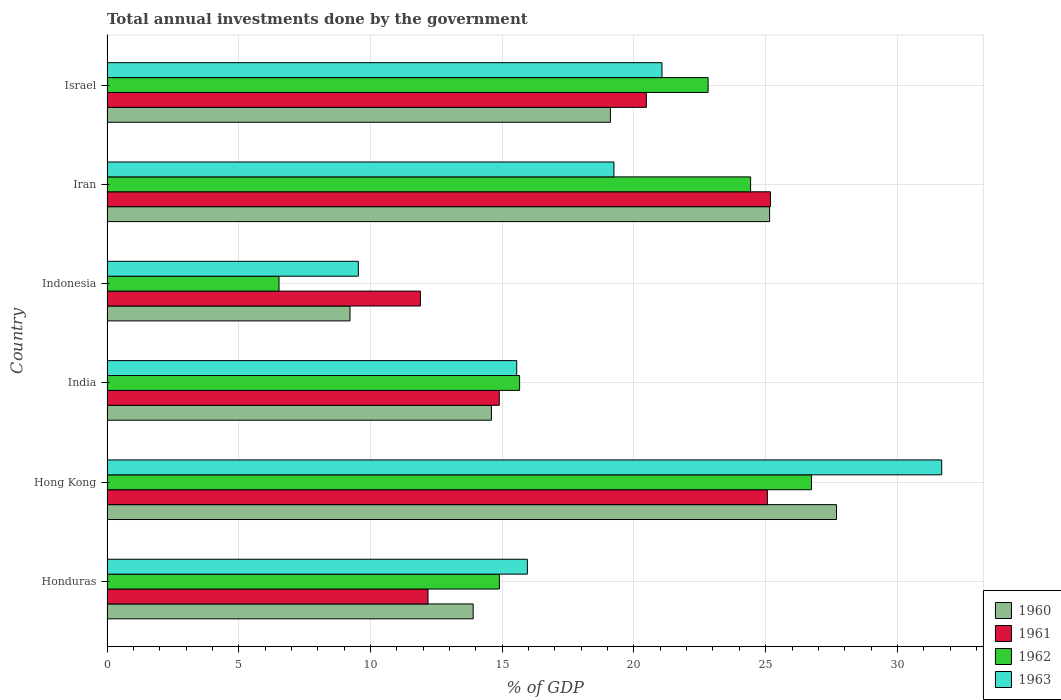Are the number of bars per tick equal to the number of legend labels?
Provide a succinct answer. Yes. What is the total annual investments done by the government in 1960 in Iran?
Make the answer very short. 25.15. Across all countries, what is the maximum total annual investments done by the government in 1962?
Give a very brief answer. 26.74. Across all countries, what is the minimum total annual investments done by the government in 1963?
Offer a terse response. 9.54. In which country was the total annual investments done by the government in 1963 maximum?
Make the answer very short. Hong Kong. What is the total total annual investments done by the government in 1961 in the graph?
Make the answer very short. 109.69. What is the difference between the total annual investments done by the government in 1960 in Honduras and that in Iran?
Make the answer very short. -11.25. What is the difference between the total annual investments done by the government in 1961 in Honduras and the total annual investments done by the government in 1963 in Israel?
Keep it short and to the point. -8.88. What is the average total annual investments done by the government in 1963 per country?
Offer a very short reply. 18.84. What is the difference between the total annual investments done by the government in 1960 and total annual investments done by the government in 1961 in India?
Your answer should be very brief. -0.3. What is the ratio of the total annual investments done by the government in 1961 in Hong Kong to that in India?
Provide a short and direct response. 1.68. Is the total annual investments done by the government in 1961 in India less than that in Indonesia?
Ensure brevity in your answer.  No. What is the difference between the highest and the second highest total annual investments done by the government in 1963?
Your answer should be compact. 10.62. What is the difference between the highest and the lowest total annual investments done by the government in 1962?
Your response must be concise. 20.21. Is it the case that in every country, the sum of the total annual investments done by the government in 1960 and total annual investments done by the government in 1961 is greater than the sum of total annual investments done by the government in 1963 and total annual investments done by the government in 1962?
Make the answer very short. No. What does the 1st bar from the top in Israel represents?
Offer a very short reply. 1963. What does the 3rd bar from the bottom in Israel represents?
Your answer should be very brief. 1962. How many bars are there?
Keep it short and to the point. 24. Are all the bars in the graph horizontal?
Give a very brief answer. Yes. How many countries are there in the graph?
Make the answer very short. 6. Does the graph contain any zero values?
Offer a very short reply. No. Does the graph contain grids?
Provide a succinct answer. Yes. Where does the legend appear in the graph?
Ensure brevity in your answer.  Bottom right. How many legend labels are there?
Your response must be concise. 4. What is the title of the graph?
Offer a terse response. Total annual investments done by the government. What is the label or title of the X-axis?
Keep it short and to the point. % of GDP. What is the % of GDP of 1960 in Honduras?
Provide a short and direct response. 13.9. What is the % of GDP in 1961 in Honduras?
Make the answer very short. 12.18. What is the % of GDP of 1962 in Honduras?
Offer a very short reply. 14.89. What is the % of GDP in 1963 in Honduras?
Your answer should be compact. 15.96. What is the % of GDP in 1960 in Hong Kong?
Your answer should be very brief. 27.69. What is the % of GDP in 1961 in Hong Kong?
Provide a short and direct response. 25.06. What is the % of GDP in 1962 in Hong Kong?
Provide a short and direct response. 26.74. What is the % of GDP in 1963 in Hong Kong?
Give a very brief answer. 31.68. What is the % of GDP in 1960 in India?
Provide a short and direct response. 14.59. What is the % of GDP of 1961 in India?
Your response must be concise. 14.89. What is the % of GDP of 1962 in India?
Your response must be concise. 15.66. What is the % of GDP in 1963 in India?
Give a very brief answer. 15.55. What is the % of GDP in 1960 in Indonesia?
Your response must be concise. 9.22. What is the % of GDP of 1961 in Indonesia?
Provide a short and direct response. 11.9. What is the % of GDP of 1962 in Indonesia?
Ensure brevity in your answer.  6.53. What is the % of GDP of 1963 in Indonesia?
Your answer should be compact. 9.54. What is the % of GDP in 1960 in Iran?
Your answer should be very brief. 25.15. What is the % of GDP of 1961 in Iran?
Your answer should be very brief. 25.18. What is the % of GDP of 1962 in Iran?
Make the answer very short. 24.43. What is the % of GDP of 1963 in Iran?
Make the answer very short. 19.24. What is the % of GDP of 1960 in Israel?
Your response must be concise. 19.11. What is the % of GDP in 1961 in Israel?
Give a very brief answer. 20.47. What is the % of GDP of 1962 in Israel?
Offer a very short reply. 22.82. What is the % of GDP in 1963 in Israel?
Provide a succinct answer. 21.06. Across all countries, what is the maximum % of GDP in 1960?
Give a very brief answer. 27.69. Across all countries, what is the maximum % of GDP in 1961?
Keep it short and to the point. 25.18. Across all countries, what is the maximum % of GDP of 1962?
Your answer should be very brief. 26.74. Across all countries, what is the maximum % of GDP of 1963?
Keep it short and to the point. 31.68. Across all countries, what is the minimum % of GDP in 1960?
Keep it short and to the point. 9.22. Across all countries, what is the minimum % of GDP in 1961?
Keep it short and to the point. 11.9. Across all countries, what is the minimum % of GDP in 1962?
Your response must be concise. 6.53. Across all countries, what is the minimum % of GDP of 1963?
Ensure brevity in your answer.  9.54. What is the total % of GDP of 1960 in the graph?
Ensure brevity in your answer.  109.66. What is the total % of GDP of 1961 in the graph?
Give a very brief answer. 109.69. What is the total % of GDP in 1962 in the graph?
Your response must be concise. 111.07. What is the total % of GDP of 1963 in the graph?
Give a very brief answer. 113.04. What is the difference between the % of GDP of 1960 in Honduras and that in Hong Kong?
Keep it short and to the point. -13.79. What is the difference between the % of GDP in 1961 in Honduras and that in Hong Kong?
Offer a very short reply. -12.88. What is the difference between the % of GDP of 1962 in Honduras and that in Hong Kong?
Make the answer very short. -11.84. What is the difference between the % of GDP of 1963 in Honduras and that in Hong Kong?
Your response must be concise. -15.73. What is the difference between the % of GDP of 1960 in Honduras and that in India?
Your response must be concise. -0.69. What is the difference between the % of GDP in 1961 in Honduras and that in India?
Your answer should be compact. -2.7. What is the difference between the % of GDP in 1962 in Honduras and that in India?
Offer a very short reply. -0.77. What is the difference between the % of GDP in 1963 in Honduras and that in India?
Keep it short and to the point. 0.4. What is the difference between the % of GDP of 1960 in Honduras and that in Indonesia?
Offer a terse response. 4.68. What is the difference between the % of GDP in 1961 in Honduras and that in Indonesia?
Give a very brief answer. 0.29. What is the difference between the % of GDP of 1962 in Honduras and that in Indonesia?
Ensure brevity in your answer.  8.36. What is the difference between the % of GDP of 1963 in Honduras and that in Indonesia?
Offer a very short reply. 6.42. What is the difference between the % of GDP in 1960 in Honduras and that in Iran?
Keep it short and to the point. -11.25. What is the difference between the % of GDP of 1961 in Honduras and that in Iran?
Your answer should be compact. -13. What is the difference between the % of GDP of 1962 in Honduras and that in Iran?
Your response must be concise. -9.54. What is the difference between the % of GDP of 1963 in Honduras and that in Iran?
Offer a very short reply. -3.29. What is the difference between the % of GDP in 1960 in Honduras and that in Israel?
Make the answer very short. -5.21. What is the difference between the % of GDP in 1961 in Honduras and that in Israel?
Ensure brevity in your answer.  -8.29. What is the difference between the % of GDP in 1962 in Honduras and that in Israel?
Give a very brief answer. -7.92. What is the difference between the % of GDP in 1963 in Honduras and that in Israel?
Provide a succinct answer. -5.11. What is the difference between the % of GDP in 1960 in Hong Kong and that in India?
Provide a short and direct response. 13.1. What is the difference between the % of GDP of 1961 in Hong Kong and that in India?
Your response must be concise. 10.18. What is the difference between the % of GDP of 1962 in Hong Kong and that in India?
Ensure brevity in your answer.  11.08. What is the difference between the % of GDP in 1963 in Hong Kong and that in India?
Make the answer very short. 16.13. What is the difference between the % of GDP in 1960 in Hong Kong and that in Indonesia?
Offer a very short reply. 18.47. What is the difference between the % of GDP in 1961 in Hong Kong and that in Indonesia?
Provide a succinct answer. 13.17. What is the difference between the % of GDP in 1962 in Hong Kong and that in Indonesia?
Make the answer very short. 20.21. What is the difference between the % of GDP in 1963 in Hong Kong and that in Indonesia?
Provide a succinct answer. 22.14. What is the difference between the % of GDP in 1960 in Hong Kong and that in Iran?
Your response must be concise. 2.54. What is the difference between the % of GDP in 1961 in Hong Kong and that in Iran?
Offer a very short reply. -0.12. What is the difference between the % of GDP of 1962 in Hong Kong and that in Iran?
Provide a succinct answer. 2.31. What is the difference between the % of GDP in 1963 in Hong Kong and that in Iran?
Make the answer very short. 12.44. What is the difference between the % of GDP in 1960 in Hong Kong and that in Israel?
Keep it short and to the point. 8.58. What is the difference between the % of GDP in 1961 in Hong Kong and that in Israel?
Provide a short and direct response. 4.59. What is the difference between the % of GDP in 1962 in Hong Kong and that in Israel?
Offer a terse response. 3.92. What is the difference between the % of GDP of 1963 in Hong Kong and that in Israel?
Your answer should be very brief. 10.62. What is the difference between the % of GDP of 1960 in India and that in Indonesia?
Offer a terse response. 5.37. What is the difference between the % of GDP of 1961 in India and that in Indonesia?
Your answer should be very brief. 2.99. What is the difference between the % of GDP in 1962 in India and that in Indonesia?
Offer a terse response. 9.13. What is the difference between the % of GDP of 1963 in India and that in Indonesia?
Give a very brief answer. 6.01. What is the difference between the % of GDP of 1960 in India and that in Iran?
Provide a short and direct response. -10.56. What is the difference between the % of GDP of 1961 in India and that in Iran?
Keep it short and to the point. -10.29. What is the difference between the % of GDP of 1962 in India and that in Iran?
Ensure brevity in your answer.  -8.77. What is the difference between the % of GDP in 1963 in India and that in Iran?
Provide a short and direct response. -3.69. What is the difference between the % of GDP in 1960 in India and that in Israel?
Your response must be concise. -4.52. What is the difference between the % of GDP in 1961 in India and that in Israel?
Ensure brevity in your answer.  -5.58. What is the difference between the % of GDP in 1962 in India and that in Israel?
Your answer should be very brief. -7.15. What is the difference between the % of GDP of 1963 in India and that in Israel?
Offer a very short reply. -5.51. What is the difference between the % of GDP of 1960 in Indonesia and that in Iran?
Offer a very short reply. -15.93. What is the difference between the % of GDP of 1961 in Indonesia and that in Iran?
Ensure brevity in your answer.  -13.29. What is the difference between the % of GDP of 1962 in Indonesia and that in Iran?
Provide a succinct answer. -17.9. What is the difference between the % of GDP of 1963 in Indonesia and that in Iran?
Your response must be concise. -9.7. What is the difference between the % of GDP in 1960 in Indonesia and that in Israel?
Offer a terse response. -9.88. What is the difference between the % of GDP of 1961 in Indonesia and that in Israel?
Provide a succinct answer. -8.58. What is the difference between the % of GDP of 1962 in Indonesia and that in Israel?
Keep it short and to the point. -16.29. What is the difference between the % of GDP in 1963 in Indonesia and that in Israel?
Offer a terse response. -11.53. What is the difference between the % of GDP in 1960 in Iran and that in Israel?
Offer a very short reply. 6.04. What is the difference between the % of GDP of 1961 in Iran and that in Israel?
Offer a very short reply. 4.71. What is the difference between the % of GDP of 1962 in Iran and that in Israel?
Offer a very short reply. 1.61. What is the difference between the % of GDP of 1963 in Iran and that in Israel?
Your response must be concise. -1.82. What is the difference between the % of GDP of 1960 in Honduras and the % of GDP of 1961 in Hong Kong?
Your answer should be very brief. -11.17. What is the difference between the % of GDP in 1960 in Honduras and the % of GDP in 1962 in Hong Kong?
Provide a short and direct response. -12.84. What is the difference between the % of GDP of 1960 in Honduras and the % of GDP of 1963 in Hong Kong?
Provide a short and direct response. -17.78. What is the difference between the % of GDP of 1961 in Honduras and the % of GDP of 1962 in Hong Kong?
Offer a very short reply. -14.55. What is the difference between the % of GDP of 1961 in Honduras and the % of GDP of 1963 in Hong Kong?
Make the answer very short. -19.5. What is the difference between the % of GDP of 1962 in Honduras and the % of GDP of 1963 in Hong Kong?
Ensure brevity in your answer.  -16.79. What is the difference between the % of GDP of 1960 in Honduras and the % of GDP of 1961 in India?
Your response must be concise. -0.99. What is the difference between the % of GDP in 1960 in Honduras and the % of GDP in 1962 in India?
Make the answer very short. -1.76. What is the difference between the % of GDP in 1960 in Honduras and the % of GDP in 1963 in India?
Offer a very short reply. -1.65. What is the difference between the % of GDP of 1961 in Honduras and the % of GDP of 1962 in India?
Your response must be concise. -3.48. What is the difference between the % of GDP of 1961 in Honduras and the % of GDP of 1963 in India?
Your response must be concise. -3.37. What is the difference between the % of GDP of 1962 in Honduras and the % of GDP of 1963 in India?
Give a very brief answer. -0.66. What is the difference between the % of GDP of 1960 in Honduras and the % of GDP of 1961 in Indonesia?
Your answer should be very brief. 2. What is the difference between the % of GDP in 1960 in Honduras and the % of GDP in 1962 in Indonesia?
Your answer should be very brief. 7.37. What is the difference between the % of GDP in 1960 in Honduras and the % of GDP in 1963 in Indonesia?
Your response must be concise. 4.36. What is the difference between the % of GDP of 1961 in Honduras and the % of GDP of 1962 in Indonesia?
Offer a very short reply. 5.65. What is the difference between the % of GDP of 1961 in Honduras and the % of GDP of 1963 in Indonesia?
Provide a short and direct response. 2.64. What is the difference between the % of GDP in 1962 in Honduras and the % of GDP in 1963 in Indonesia?
Keep it short and to the point. 5.35. What is the difference between the % of GDP of 1960 in Honduras and the % of GDP of 1961 in Iran?
Give a very brief answer. -11.28. What is the difference between the % of GDP in 1960 in Honduras and the % of GDP in 1962 in Iran?
Ensure brevity in your answer.  -10.53. What is the difference between the % of GDP in 1960 in Honduras and the % of GDP in 1963 in Iran?
Give a very brief answer. -5.34. What is the difference between the % of GDP of 1961 in Honduras and the % of GDP of 1962 in Iran?
Make the answer very short. -12.24. What is the difference between the % of GDP of 1961 in Honduras and the % of GDP of 1963 in Iran?
Your answer should be compact. -7.06. What is the difference between the % of GDP of 1962 in Honduras and the % of GDP of 1963 in Iran?
Offer a very short reply. -4.35. What is the difference between the % of GDP in 1960 in Honduras and the % of GDP in 1961 in Israel?
Your answer should be very brief. -6.57. What is the difference between the % of GDP of 1960 in Honduras and the % of GDP of 1962 in Israel?
Provide a succinct answer. -8.92. What is the difference between the % of GDP in 1960 in Honduras and the % of GDP in 1963 in Israel?
Offer a very short reply. -7.17. What is the difference between the % of GDP in 1961 in Honduras and the % of GDP in 1962 in Israel?
Ensure brevity in your answer.  -10.63. What is the difference between the % of GDP of 1961 in Honduras and the % of GDP of 1963 in Israel?
Keep it short and to the point. -8.88. What is the difference between the % of GDP of 1962 in Honduras and the % of GDP of 1963 in Israel?
Offer a very short reply. -6.17. What is the difference between the % of GDP of 1960 in Hong Kong and the % of GDP of 1961 in India?
Keep it short and to the point. 12.8. What is the difference between the % of GDP of 1960 in Hong Kong and the % of GDP of 1962 in India?
Ensure brevity in your answer.  12.03. What is the difference between the % of GDP in 1960 in Hong Kong and the % of GDP in 1963 in India?
Offer a terse response. 12.14. What is the difference between the % of GDP in 1961 in Hong Kong and the % of GDP in 1962 in India?
Offer a very short reply. 9.4. What is the difference between the % of GDP of 1961 in Hong Kong and the % of GDP of 1963 in India?
Provide a short and direct response. 9.51. What is the difference between the % of GDP in 1962 in Hong Kong and the % of GDP in 1963 in India?
Give a very brief answer. 11.19. What is the difference between the % of GDP of 1960 in Hong Kong and the % of GDP of 1961 in Indonesia?
Your answer should be very brief. 15.79. What is the difference between the % of GDP in 1960 in Hong Kong and the % of GDP in 1962 in Indonesia?
Provide a short and direct response. 21.16. What is the difference between the % of GDP in 1960 in Hong Kong and the % of GDP in 1963 in Indonesia?
Your response must be concise. 18.15. What is the difference between the % of GDP in 1961 in Hong Kong and the % of GDP in 1962 in Indonesia?
Provide a short and direct response. 18.54. What is the difference between the % of GDP in 1961 in Hong Kong and the % of GDP in 1963 in Indonesia?
Offer a very short reply. 15.53. What is the difference between the % of GDP of 1962 in Hong Kong and the % of GDP of 1963 in Indonesia?
Your answer should be very brief. 17.2. What is the difference between the % of GDP of 1960 in Hong Kong and the % of GDP of 1961 in Iran?
Your response must be concise. 2.51. What is the difference between the % of GDP of 1960 in Hong Kong and the % of GDP of 1962 in Iran?
Ensure brevity in your answer.  3.26. What is the difference between the % of GDP in 1960 in Hong Kong and the % of GDP in 1963 in Iran?
Your response must be concise. 8.45. What is the difference between the % of GDP of 1961 in Hong Kong and the % of GDP of 1962 in Iran?
Ensure brevity in your answer.  0.64. What is the difference between the % of GDP in 1961 in Hong Kong and the % of GDP in 1963 in Iran?
Provide a short and direct response. 5.82. What is the difference between the % of GDP of 1962 in Hong Kong and the % of GDP of 1963 in Iran?
Give a very brief answer. 7.5. What is the difference between the % of GDP of 1960 in Hong Kong and the % of GDP of 1961 in Israel?
Offer a very short reply. 7.22. What is the difference between the % of GDP of 1960 in Hong Kong and the % of GDP of 1962 in Israel?
Provide a short and direct response. 4.87. What is the difference between the % of GDP in 1960 in Hong Kong and the % of GDP in 1963 in Israel?
Your response must be concise. 6.62. What is the difference between the % of GDP in 1961 in Hong Kong and the % of GDP in 1962 in Israel?
Ensure brevity in your answer.  2.25. What is the difference between the % of GDP of 1961 in Hong Kong and the % of GDP of 1963 in Israel?
Your answer should be compact. 4. What is the difference between the % of GDP of 1962 in Hong Kong and the % of GDP of 1963 in Israel?
Offer a very short reply. 5.67. What is the difference between the % of GDP of 1960 in India and the % of GDP of 1961 in Indonesia?
Make the answer very short. 2.7. What is the difference between the % of GDP of 1960 in India and the % of GDP of 1962 in Indonesia?
Keep it short and to the point. 8.06. What is the difference between the % of GDP in 1960 in India and the % of GDP in 1963 in Indonesia?
Make the answer very short. 5.05. What is the difference between the % of GDP in 1961 in India and the % of GDP in 1962 in Indonesia?
Keep it short and to the point. 8.36. What is the difference between the % of GDP of 1961 in India and the % of GDP of 1963 in Indonesia?
Your response must be concise. 5.35. What is the difference between the % of GDP of 1962 in India and the % of GDP of 1963 in Indonesia?
Offer a terse response. 6.12. What is the difference between the % of GDP of 1960 in India and the % of GDP of 1961 in Iran?
Ensure brevity in your answer.  -10.59. What is the difference between the % of GDP in 1960 in India and the % of GDP in 1962 in Iran?
Your answer should be compact. -9.84. What is the difference between the % of GDP of 1960 in India and the % of GDP of 1963 in Iran?
Provide a succinct answer. -4.65. What is the difference between the % of GDP in 1961 in India and the % of GDP in 1962 in Iran?
Your answer should be very brief. -9.54. What is the difference between the % of GDP in 1961 in India and the % of GDP in 1963 in Iran?
Your response must be concise. -4.35. What is the difference between the % of GDP in 1962 in India and the % of GDP in 1963 in Iran?
Your answer should be very brief. -3.58. What is the difference between the % of GDP of 1960 in India and the % of GDP of 1961 in Israel?
Keep it short and to the point. -5.88. What is the difference between the % of GDP in 1960 in India and the % of GDP in 1962 in Israel?
Your answer should be compact. -8.22. What is the difference between the % of GDP in 1960 in India and the % of GDP in 1963 in Israel?
Make the answer very short. -6.47. What is the difference between the % of GDP of 1961 in India and the % of GDP of 1962 in Israel?
Ensure brevity in your answer.  -7.93. What is the difference between the % of GDP of 1961 in India and the % of GDP of 1963 in Israel?
Give a very brief answer. -6.18. What is the difference between the % of GDP of 1962 in India and the % of GDP of 1963 in Israel?
Offer a very short reply. -5.4. What is the difference between the % of GDP of 1960 in Indonesia and the % of GDP of 1961 in Iran?
Your response must be concise. -15.96. What is the difference between the % of GDP of 1960 in Indonesia and the % of GDP of 1962 in Iran?
Offer a terse response. -15.21. What is the difference between the % of GDP in 1960 in Indonesia and the % of GDP in 1963 in Iran?
Provide a succinct answer. -10.02. What is the difference between the % of GDP of 1961 in Indonesia and the % of GDP of 1962 in Iran?
Offer a very short reply. -12.53. What is the difference between the % of GDP in 1961 in Indonesia and the % of GDP in 1963 in Iran?
Make the answer very short. -7.35. What is the difference between the % of GDP of 1962 in Indonesia and the % of GDP of 1963 in Iran?
Give a very brief answer. -12.71. What is the difference between the % of GDP in 1960 in Indonesia and the % of GDP in 1961 in Israel?
Your response must be concise. -11.25. What is the difference between the % of GDP in 1960 in Indonesia and the % of GDP in 1962 in Israel?
Your response must be concise. -13.59. What is the difference between the % of GDP of 1960 in Indonesia and the % of GDP of 1963 in Israel?
Your response must be concise. -11.84. What is the difference between the % of GDP in 1961 in Indonesia and the % of GDP in 1962 in Israel?
Ensure brevity in your answer.  -10.92. What is the difference between the % of GDP of 1961 in Indonesia and the % of GDP of 1963 in Israel?
Provide a succinct answer. -9.17. What is the difference between the % of GDP of 1962 in Indonesia and the % of GDP of 1963 in Israel?
Provide a short and direct response. -14.54. What is the difference between the % of GDP of 1960 in Iran and the % of GDP of 1961 in Israel?
Your answer should be compact. 4.68. What is the difference between the % of GDP of 1960 in Iran and the % of GDP of 1962 in Israel?
Provide a succinct answer. 2.33. What is the difference between the % of GDP of 1960 in Iran and the % of GDP of 1963 in Israel?
Ensure brevity in your answer.  4.08. What is the difference between the % of GDP in 1961 in Iran and the % of GDP in 1962 in Israel?
Offer a terse response. 2.37. What is the difference between the % of GDP in 1961 in Iran and the % of GDP in 1963 in Israel?
Keep it short and to the point. 4.12. What is the difference between the % of GDP in 1962 in Iran and the % of GDP in 1963 in Israel?
Your answer should be compact. 3.36. What is the average % of GDP in 1960 per country?
Make the answer very short. 18.28. What is the average % of GDP in 1961 per country?
Your response must be concise. 18.28. What is the average % of GDP in 1962 per country?
Ensure brevity in your answer.  18.51. What is the average % of GDP in 1963 per country?
Provide a short and direct response. 18.84. What is the difference between the % of GDP in 1960 and % of GDP in 1961 in Honduras?
Provide a succinct answer. 1.71. What is the difference between the % of GDP in 1960 and % of GDP in 1962 in Honduras?
Ensure brevity in your answer.  -1. What is the difference between the % of GDP of 1960 and % of GDP of 1963 in Honduras?
Give a very brief answer. -2.06. What is the difference between the % of GDP of 1961 and % of GDP of 1962 in Honduras?
Give a very brief answer. -2.71. What is the difference between the % of GDP in 1961 and % of GDP in 1963 in Honduras?
Your answer should be very brief. -3.77. What is the difference between the % of GDP in 1962 and % of GDP in 1963 in Honduras?
Your response must be concise. -1.06. What is the difference between the % of GDP in 1960 and % of GDP in 1961 in Hong Kong?
Provide a short and direct response. 2.62. What is the difference between the % of GDP in 1960 and % of GDP in 1962 in Hong Kong?
Provide a short and direct response. 0.95. What is the difference between the % of GDP of 1960 and % of GDP of 1963 in Hong Kong?
Offer a terse response. -3.99. What is the difference between the % of GDP in 1961 and % of GDP in 1962 in Hong Kong?
Make the answer very short. -1.67. What is the difference between the % of GDP in 1961 and % of GDP in 1963 in Hong Kong?
Give a very brief answer. -6.62. What is the difference between the % of GDP in 1962 and % of GDP in 1963 in Hong Kong?
Offer a terse response. -4.94. What is the difference between the % of GDP in 1960 and % of GDP in 1961 in India?
Give a very brief answer. -0.3. What is the difference between the % of GDP in 1960 and % of GDP in 1962 in India?
Offer a very short reply. -1.07. What is the difference between the % of GDP in 1960 and % of GDP in 1963 in India?
Provide a succinct answer. -0.96. What is the difference between the % of GDP in 1961 and % of GDP in 1962 in India?
Offer a very short reply. -0.77. What is the difference between the % of GDP of 1961 and % of GDP of 1963 in India?
Make the answer very short. -0.66. What is the difference between the % of GDP in 1962 and % of GDP in 1963 in India?
Your answer should be compact. 0.11. What is the difference between the % of GDP in 1960 and % of GDP in 1961 in Indonesia?
Your answer should be compact. -2.67. What is the difference between the % of GDP of 1960 and % of GDP of 1962 in Indonesia?
Provide a succinct answer. 2.69. What is the difference between the % of GDP of 1960 and % of GDP of 1963 in Indonesia?
Give a very brief answer. -0.32. What is the difference between the % of GDP of 1961 and % of GDP of 1962 in Indonesia?
Provide a short and direct response. 5.37. What is the difference between the % of GDP in 1961 and % of GDP in 1963 in Indonesia?
Offer a very short reply. 2.36. What is the difference between the % of GDP of 1962 and % of GDP of 1963 in Indonesia?
Give a very brief answer. -3.01. What is the difference between the % of GDP in 1960 and % of GDP in 1961 in Iran?
Offer a very short reply. -0.03. What is the difference between the % of GDP of 1960 and % of GDP of 1962 in Iran?
Provide a succinct answer. 0.72. What is the difference between the % of GDP in 1960 and % of GDP in 1963 in Iran?
Your answer should be compact. 5.91. What is the difference between the % of GDP in 1961 and % of GDP in 1962 in Iran?
Make the answer very short. 0.75. What is the difference between the % of GDP in 1961 and % of GDP in 1963 in Iran?
Offer a very short reply. 5.94. What is the difference between the % of GDP in 1962 and % of GDP in 1963 in Iran?
Offer a terse response. 5.19. What is the difference between the % of GDP in 1960 and % of GDP in 1961 in Israel?
Ensure brevity in your answer.  -1.36. What is the difference between the % of GDP of 1960 and % of GDP of 1962 in Israel?
Your answer should be compact. -3.71. What is the difference between the % of GDP of 1960 and % of GDP of 1963 in Israel?
Your answer should be very brief. -1.96. What is the difference between the % of GDP in 1961 and % of GDP in 1962 in Israel?
Make the answer very short. -2.34. What is the difference between the % of GDP of 1961 and % of GDP of 1963 in Israel?
Your response must be concise. -0.59. What is the difference between the % of GDP of 1962 and % of GDP of 1963 in Israel?
Ensure brevity in your answer.  1.75. What is the ratio of the % of GDP in 1960 in Honduras to that in Hong Kong?
Make the answer very short. 0.5. What is the ratio of the % of GDP of 1961 in Honduras to that in Hong Kong?
Provide a succinct answer. 0.49. What is the ratio of the % of GDP in 1962 in Honduras to that in Hong Kong?
Offer a terse response. 0.56. What is the ratio of the % of GDP of 1963 in Honduras to that in Hong Kong?
Keep it short and to the point. 0.5. What is the ratio of the % of GDP in 1960 in Honduras to that in India?
Keep it short and to the point. 0.95. What is the ratio of the % of GDP in 1961 in Honduras to that in India?
Give a very brief answer. 0.82. What is the ratio of the % of GDP in 1962 in Honduras to that in India?
Ensure brevity in your answer.  0.95. What is the ratio of the % of GDP of 1963 in Honduras to that in India?
Your response must be concise. 1.03. What is the ratio of the % of GDP in 1960 in Honduras to that in Indonesia?
Offer a terse response. 1.51. What is the ratio of the % of GDP in 1961 in Honduras to that in Indonesia?
Make the answer very short. 1.02. What is the ratio of the % of GDP in 1962 in Honduras to that in Indonesia?
Give a very brief answer. 2.28. What is the ratio of the % of GDP in 1963 in Honduras to that in Indonesia?
Provide a succinct answer. 1.67. What is the ratio of the % of GDP in 1960 in Honduras to that in Iran?
Give a very brief answer. 0.55. What is the ratio of the % of GDP in 1961 in Honduras to that in Iran?
Provide a succinct answer. 0.48. What is the ratio of the % of GDP in 1962 in Honduras to that in Iran?
Offer a very short reply. 0.61. What is the ratio of the % of GDP of 1963 in Honduras to that in Iran?
Your response must be concise. 0.83. What is the ratio of the % of GDP of 1960 in Honduras to that in Israel?
Offer a terse response. 0.73. What is the ratio of the % of GDP of 1961 in Honduras to that in Israel?
Give a very brief answer. 0.6. What is the ratio of the % of GDP in 1962 in Honduras to that in Israel?
Give a very brief answer. 0.65. What is the ratio of the % of GDP of 1963 in Honduras to that in Israel?
Provide a succinct answer. 0.76. What is the ratio of the % of GDP in 1960 in Hong Kong to that in India?
Give a very brief answer. 1.9. What is the ratio of the % of GDP in 1961 in Hong Kong to that in India?
Ensure brevity in your answer.  1.68. What is the ratio of the % of GDP of 1962 in Hong Kong to that in India?
Make the answer very short. 1.71. What is the ratio of the % of GDP in 1963 in Hong Kong to that in India?
Your answer should be very brief. 2.04. What is the ratio of the % of GDP in 1960 in Hong Kong to that in Indonesia?
Give a very brief answer. 3. What is the ratio of the % of GDP of 1961 in Hong Kong to that in Indonesia?
Offer a very short reply. 2.11. What is the ratio of the % of GDP of 1962 in Hong Kong to that in Indonesia?
Give a very brief answer. 4.09. What is the ratio of the % of GDP in 1963 in Hong Kong to that in Indonesia?
Provide a short and direct response. 3.32. What is the ratio of the % of GDP of 1960 in Hong Kong to that in Iran?
Give a very brief answer. 1.1. What is the ratio of the % of GDP of 1961 in Hong Kong to that in Iran?
Give a very brief answer. 1. What is the ratio of the % of GDP in 1962 in Hong Kong to that in Iran?
Make the answer very short. 1.09. What is the ratio of the % of GDP in 1963 in Hong Kong to that in Iran?
Your answer should be compact. 1.65. What is the ratio of the % of GDP of 1960 in Hong Kong to that in Israel?
Your answer should be compact. 1.45. What is the ratio of the % of GDP in 1961 in Hong Kong to that in Israel?
Ensure brevity in your answer.  1.22. What is the ratio of the % of GDP of 1962 in Hong Kong to that in Israel?
Your response must be concise. 1.17. What is the ratio of the % of GDP in 1963 in Hong Kong to that in Israel?
Offer a terse response. 1.5. What is the ratio of the % of GDP of 1960 in India to that in Indonesia?
Offer a very short reply. 1.58. What is the ratio of the % of GDP in 1961 in India to that in Indonesia?
Make the answer very short. 1.25. What is the ratio of the % of GDP of 1962 in India to that in Indonesia?
Provide a succinct answer. 2.4. What is the ratio of the % of GDP of 1963 in India to that in Indonesia?
Give a very brief answer. 1.63. What is the ratio of the % of GDP in 1960 in India to that in Iran?
Offer a terse response. 0.58. What is the ratio of the % of GDP in 1961 in India to that in Iran?
Offer a terse response. 0.59. What is the ratio of the % of GDP of 1962 in India to that in Iran?
Make the answer very short. 0.64. What is the ratio of the % of GDP of 1963 in India to that in Iran?
Provide a succinct answer. 0.81. What is the ratio of the % of GDP of 1960 in India to that in Israel?
Keep it short and to the point. 0.76. What is the ratio of the % of GDP in 1961 in India to that in Israel?
Provide a succinct answer. 0.73. What is the ratio of the % of GDP of 1962 in India to that in Israel?
Ensure brevity in your answer.  0.69. What is the ratio of the % of GDP of 1963 in India to that in Israel?
Your response must be concise. 0.74. What is the ratio of the % of GDP of 1960 in Indonesia to that in Iran?
Ensure brevity in your answer.  0.37. What is the ratio of the % of GDP in 1961 in Indonesia to that in Iran?
Provide a short and direct response. 0.47. What is the ratio of the % of GDP of 1962 in Indonesia to that in Iran?
Your response must be concise. 0.27. What is the ratio of the % of GDP of 1963 in Indonesia to that in Iran?
Offer a terse response. 0.5. What is the ratio of the % of GDP of 1960 in Indonesia to that in Israel?
Keep it short and to the point. 0.48. What is the ratio of the % of GDP of 1961 in Indonesia to that in Israel?
Provide a short and direct response. 0.58. What is the ratio of the % of GDP in 1962 in Indonesia to that in Israel?
Provide a succinct answer. 0.29. What is the ratio of the % of GDP in 1963 in Indonesia to that in Israel?
Provide a succinct answer. 0.45. What is the ratio of the % of GDP in 1960 in Iran to that in Israel?
Keep it short and to the point. 1.32. What is the ratio of the % of GDP in 1961 in Iran to that in Israel?
Ensure brevity in your answer.  1.23. What is the ratio of the % of GDP of 1962 in Iran to that in Israel?
Offer a terse response. 1.07. What is the ratio of the % of GDP in 1963 in Iran to that in Israel?
Provide a succinct answer. 0.91. What is the difference between the highest and the second highest % of GDP of 1960?
Offer a terse response. 2.54. What is the difference between the highest and the second highest % of GDP of 1961?
Provide a short and direct response. 0.12. What is the difference between the highest and the second highest % of GDP of 1962?
Your answer should be very brief. 2.31. What is the difference between the highest and the second highest % of GDP in 1963?
Ensure brevity in your answer.  10.62. What is the difference between the highest and the lowest % of GDP in 1960?
Provide a short and direct response. 18.47. What is the difference between the highest and the lowest % of GDP in 1961?
Offer a very short reply. 13.29. What is the difference between the highest and the lowest % of GDP of 1962?
Make the answer very short. 20.21. What is the difference between the highest and the lowest % of GDP of 1963?
Provide a succinct answer. 22.14. 